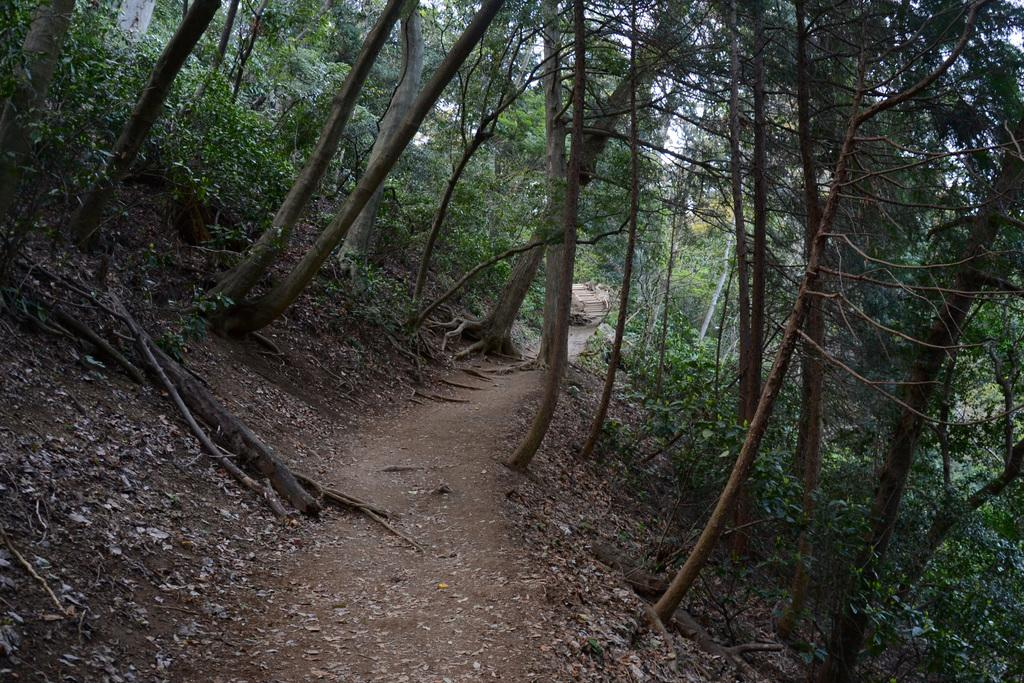What type of vegetation can be seen in the image? There are many trees and plants in the image. What is the primary feature at the bottom of the image? There is a walkway at the bottom of the image. What type of pancake is being served on the walkway in the image? There is no pancake present in the image; it only features trees, plants, and a walkway. 